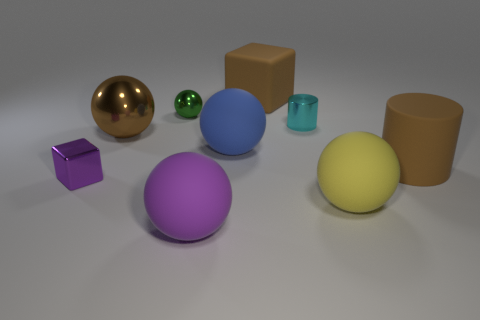Do the objects cast shadows, and what can we infer from them? Each object casts a shadow, indicating a single light source from above. The shadows also suggest the objects are resting on a flat surface. Can we determine the light source direction? Based on the shadows, the light source appears to be coming from the upper left of the image. 